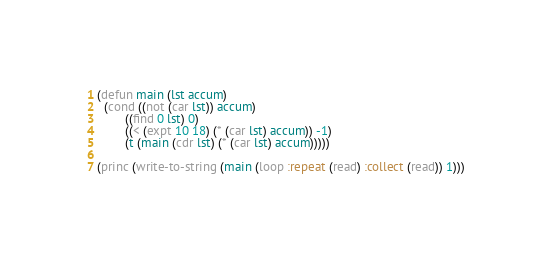Convert code to text. <code><loc_0><loc_0><loc_500><loc_500><_Lisp_>(defun main (lst accum)
  (cond ((not (car lst)) accum)
        ((find 0 lst) 0)
        ((< (expt 10 18) (* (car lst) accum)) -1)
        (t (main (cdr lst) (* (car lst) accum)))))

(princ (write-to-string (main (loop :repeat (read) :collect (read)) 1)))
</code> 